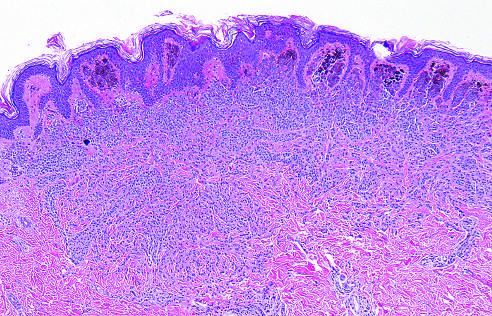what is a nevus composed of?
Answer the question using a single word or phrase. Melanocytes 